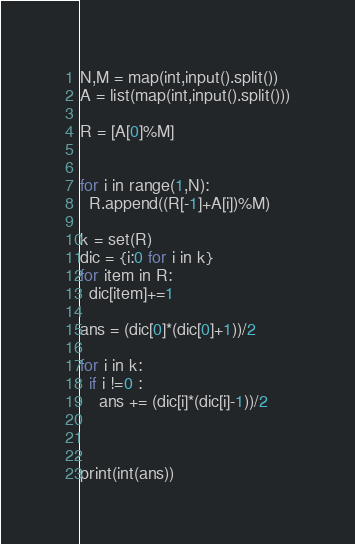<code> <loc_0><loc_0><loc_500><loc_500><_Python_>N,M = map(int,input().split())
A = list(map(int,input().split()))

R = [A[0]%M]


for i in range(1,N):
  R.append((R[-1]+A[i])%M)

k = set(R)
dic = {i:0 for i in k}
for item in R:
  dic[item]+=1

ans = (dic[0]*(dic[0]+1))/2

for i in k:
  if i !=0 :
    ans += (dic[i]*(dic[i]-1))/2
    

    
print(int(ans))
</code> 